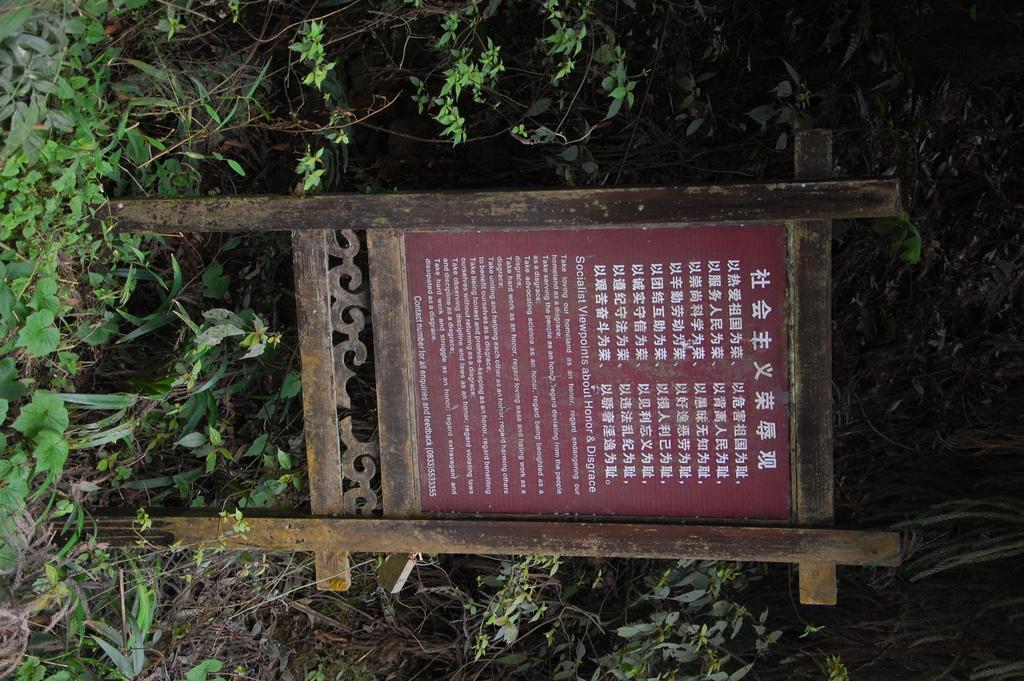In one or two sentences, can you explain what this image depicts? In this picture we can see board, wooden poles, plants, leaves and stems. 